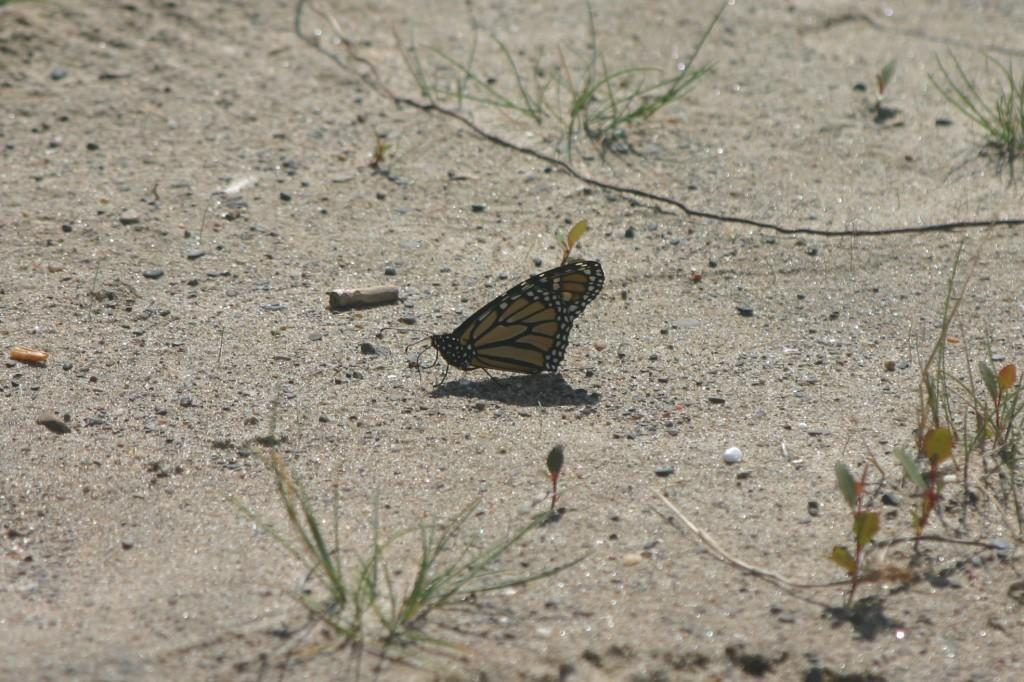What types of surfaces are present at the bottom of the picture? There is sand and grass at the bottom of the picture. What is the main subject in the middle of the picture? There is a butterfly in the middle of the picture. What colors can be seen on the butterfly? The butterfly has yellow and black colors. How would you describe the background of the image? The background of the image is blurred. What is the price of the meat in the image? There is no meat present in the image, so it is not possible to determine its price. 